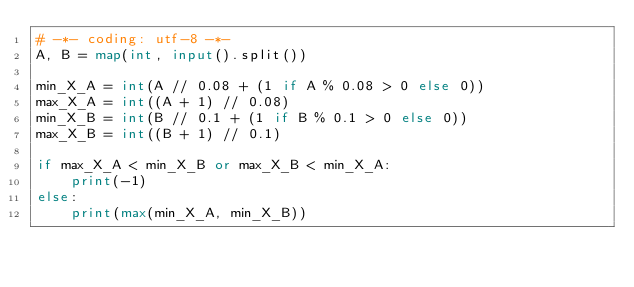<code> <loc_0><loc_0><loc_500><loc_500><_Python_># -*- coding: utf-8 -*-
A, B = map(int, input().split())

min_X_A = int(A // 0.08 + (1 if A % 0.08 > 0 else 0))
max_X_A = int((A + 1) // 0.08)
min_X_B = int(B // 0.1 + (1 if B % 0.1 > 0 else 0))
max_X_B = int((B + 1) // 0.1)

if max_X_A < min_X_B or max_X_B < min_X_A:
    print(-1)
else:
    print(max(min_X_A, min_X_B))</code> 